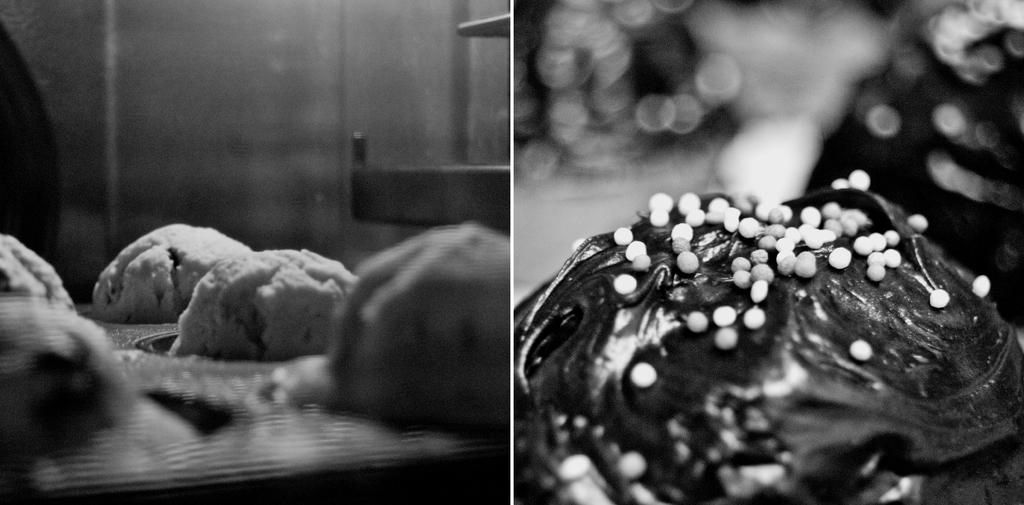What type of image is displayed? The image contains a collage of different food items. What is the color scheme of the image? The image is black and white. Where is the bottle placed in the image? There is no bottle present in the image. What events are depicted on the calendar in the image? There is no calendar present in the image. 